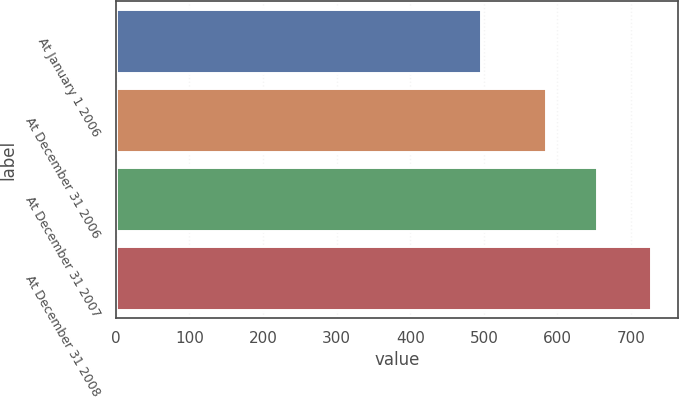Convert chart to OTSL. <chart><loc_0><loc_0><loc_500><loc_500><bar_chart><fcel>At January 1 2006<fcel>At December 31 2006<fcel>At December 31 2007<fcel>At December 31 2008<nl><fcel>496<fcel>585<fcel>654<fcel>727<nl></chart> 